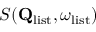Convert formula to latex. <formula><loc_0><loc_0><loc_500><loc_500>S ( Q _ { l i s t } , \omega _ { l i s t } )</formula> 